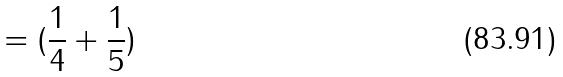<formula> <loc_0><loc_0><loc_500><loc_500>= ( \frac { 1 } { 4 } + \frac { 1 } { 5 } )</formula> 